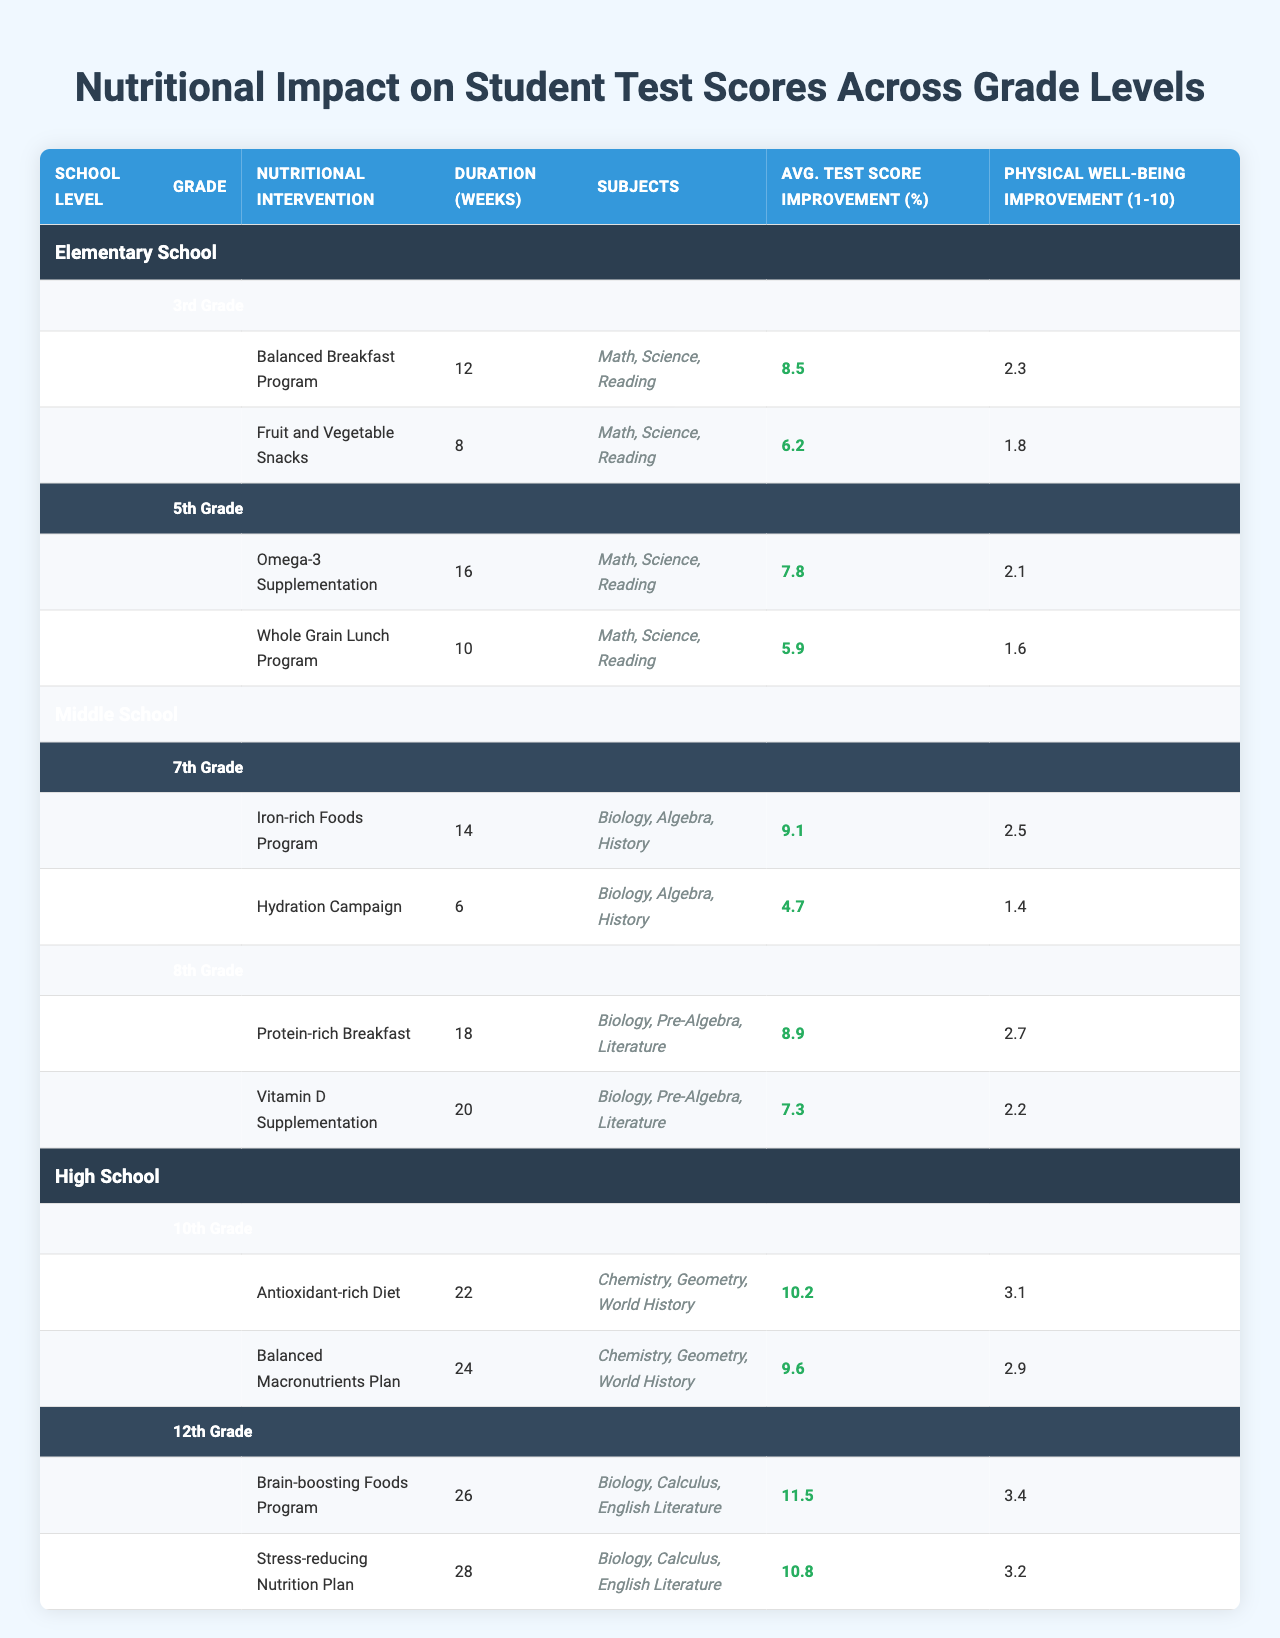What is the highest average test score improvement among interventions in 10th grade? In the 10th grade, the interventions are "Antioxidant-rich Diet" with 10.2% improvement and "Balanced Macronutrients Plan" with 9.6%. The higher value is 10.2%.
Answer: 10.2% Which nutritional intervention in 8th grade had the least physical well-being improvement? In the 8th grade, "Protein-rich Breakfast" has a physical well-being improvement of 2.7, whereas "Vitamin D Supplementation" has an improvement of 2.2. The lesser value is 2.2.
Answer: 2.2 How many weeks did the "Balanced Breakfast Program" last? The "Balanced Breakfast Program" had a duration of 12 weeks as indicated in the table under the 3rd grade interventions.
Answer: 12 weeks Which grade level had an intervention with the highest average test score improvement? The 12th grade interventions both had average test score improvements of 11.5% and 10.8%, the highest improvements when compared to other grades.
Answer: 12th grade What is the overall average test score improvement for 5th grade interventions? The 5th grade interventions showed improvements of 7.8% and 5.9%. Summing these gives 13.7%, and averaging over 2 interventions gives 13.7/2 = 6.85%.
Answer: 6.85% Did any interventions in middle school lead to at least a 9% improvement in average test scores? Yes, the "Iron-rich Foods Program" in 7th grade showed a 9.1% improvement and the "Protein-rich Breakfast" in 8th grade showed an 8.9%.
Answer: Yes What is the difference in average test score improvement between the "Balanced Macronutrients Plan" and the "Brain-boosting Foods Program"? The "Balanced Macronutrients Plan" had an improvement of 9.6%, while the "Brain-boosting Foods Program" had 11.5%. The difference is 11.5% - 9.6% = 1.9%.
Answer: 1.9% Which nutritional intervention had the longest duration in middle school? The "Iron-rich Foods Program" lasted for 14 weeks, which is the longest duration of the middle school interventions.
Answer: 14 weeks Which grade level had the highest physical well-being improvement score across all interventions? The 12th grade interventions, particularly "Brain-boosting Foods Program," showed a physical well-being improvement score of 3.4, the highest among all grade levels.
Answer: 3.4 What is the average duration of all nutritional interventions listed for elementary school? The durations for 3rd grade are 12 and 8 weeks; for 5th grade it's 16 and 10 weeks, summing these gives 46 weeks. Averaging over 4 interventions gives 46/4 = 11.5 weeks.
Answer: 11.5 weeks Is there an intervention that improved test scores by more than 10% in high school? Yes, the "Brain-boosting Foods Program" in 12th grade improved scores by 11.5%, which is greater than 10%.
Answer: Yes 